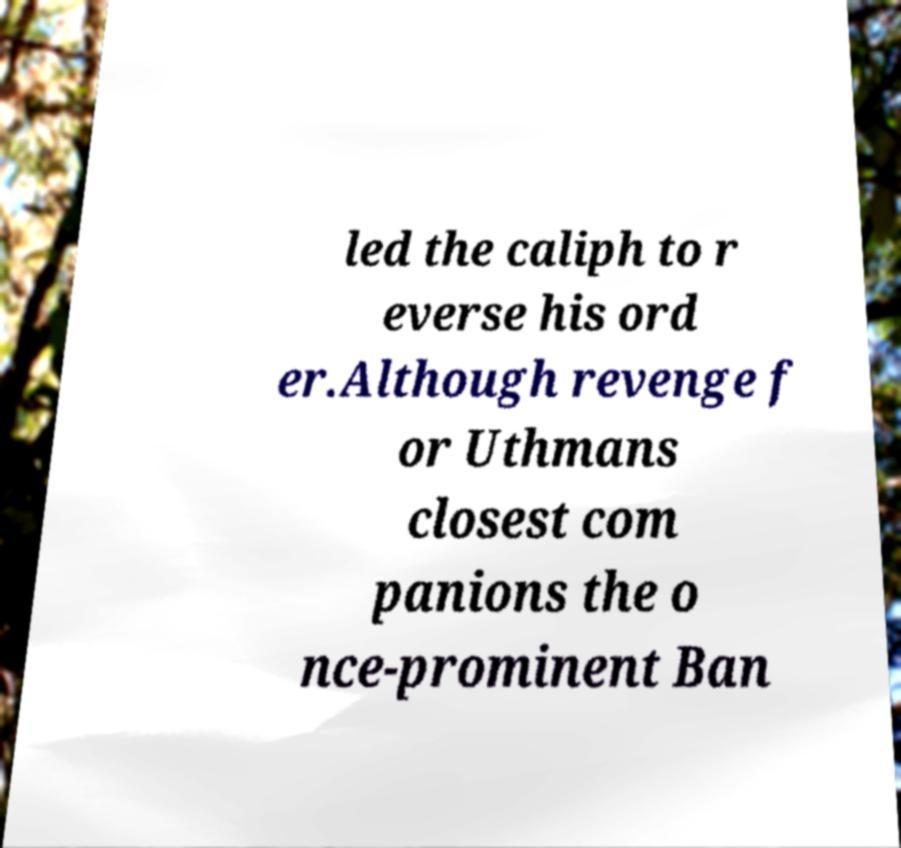There's text embedded in this image that I need extracted. Can you transcribe it verbatim? led the caliph to r everse his ord er.Although revenge f or Uthmans closest com panions the o nce-prominent Ban 